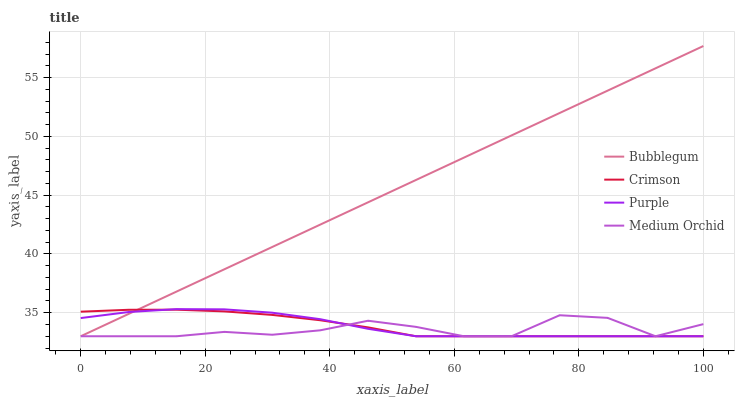Does Medium Orchid have the minimum area under the curve?
Answer yes or no. Yes. Does Bubblegum have the maximum area under the curve?
Answer yes or no. Yes. Does Purple have the minimum area under the curve?
Answer yes or no. No. Does Purple have the maximum area under the curve?
Answer yes or no. No. Is Bubblegum the smoothest?
Answer yes or no. Yes. Is Medium Orchid the roughest?
Answer yes or no. Yes. Is Purple the smoothest?
Answer yes or no. No. Is Purple the roughest?
Answer yes or no. No. Does Crimson have the lowest value?
Answer yes or no. Yes. Does Bubblegum have the highest value?
Answer yes or no. Yes. Does Purple have the highest value?
Answer yes or no. No. Does Purple intersect Medium Orchid?
Answer yes or no. Yes. Is Purple less than Medium Orchid?
Answer yes or no. No. Is Purple greater than Medium Orchid?
Answer yes or no. No. 